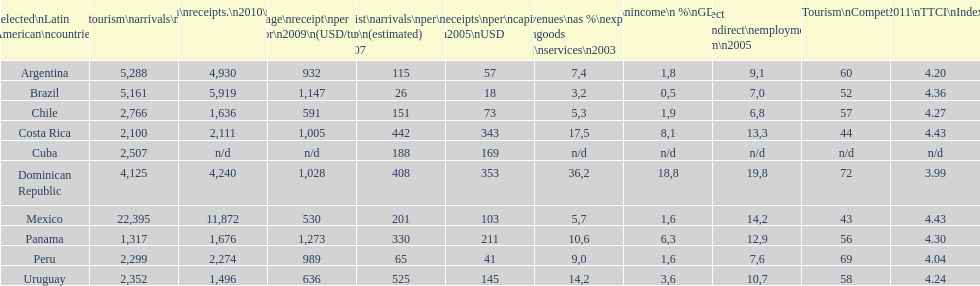Which nation holds the top position across numerous categories? Dominican Republic. 